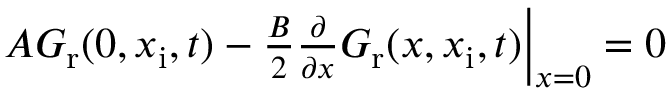Convert formula to latex. <formula><loc_0><loc_0><loc_500><loc_500>\begin{array} { r } { A G _ { r } ( 0 , x _ { i } , t ) - \frac { B } { 2 } \frac { \partial } { \partial x } G _ { r } ( x , x _ { i } , t ) \right | _ { x = 0 } = 0 } \end{array}</formula> 